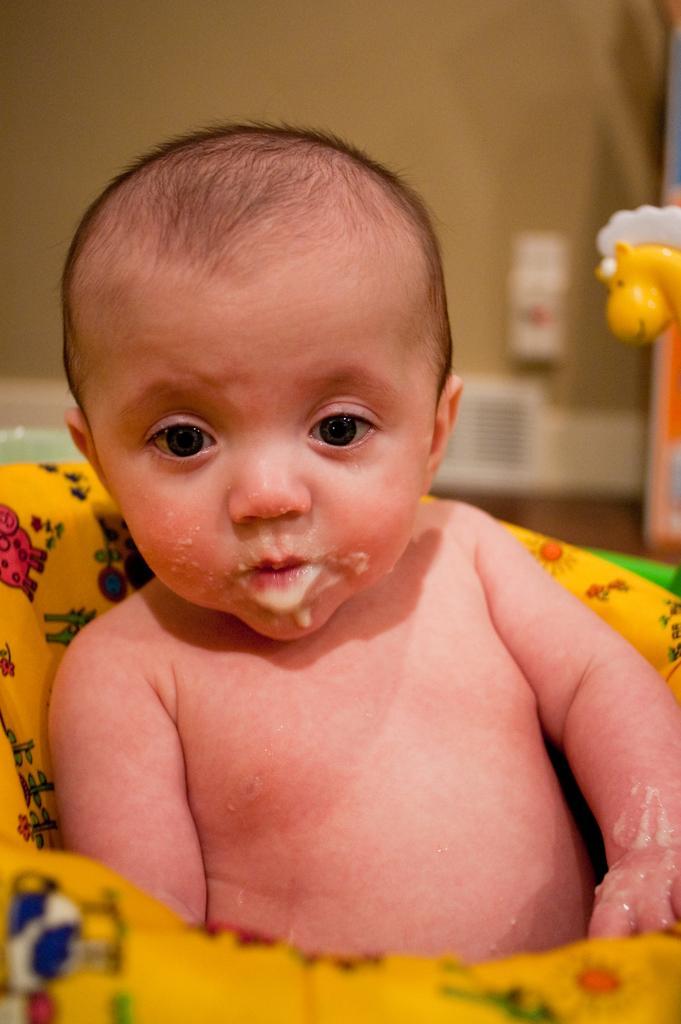Describe this image in one or two sentences. In this image I can see a baby is in the yellow color cloth. On the right side there is the yellow color doll. 